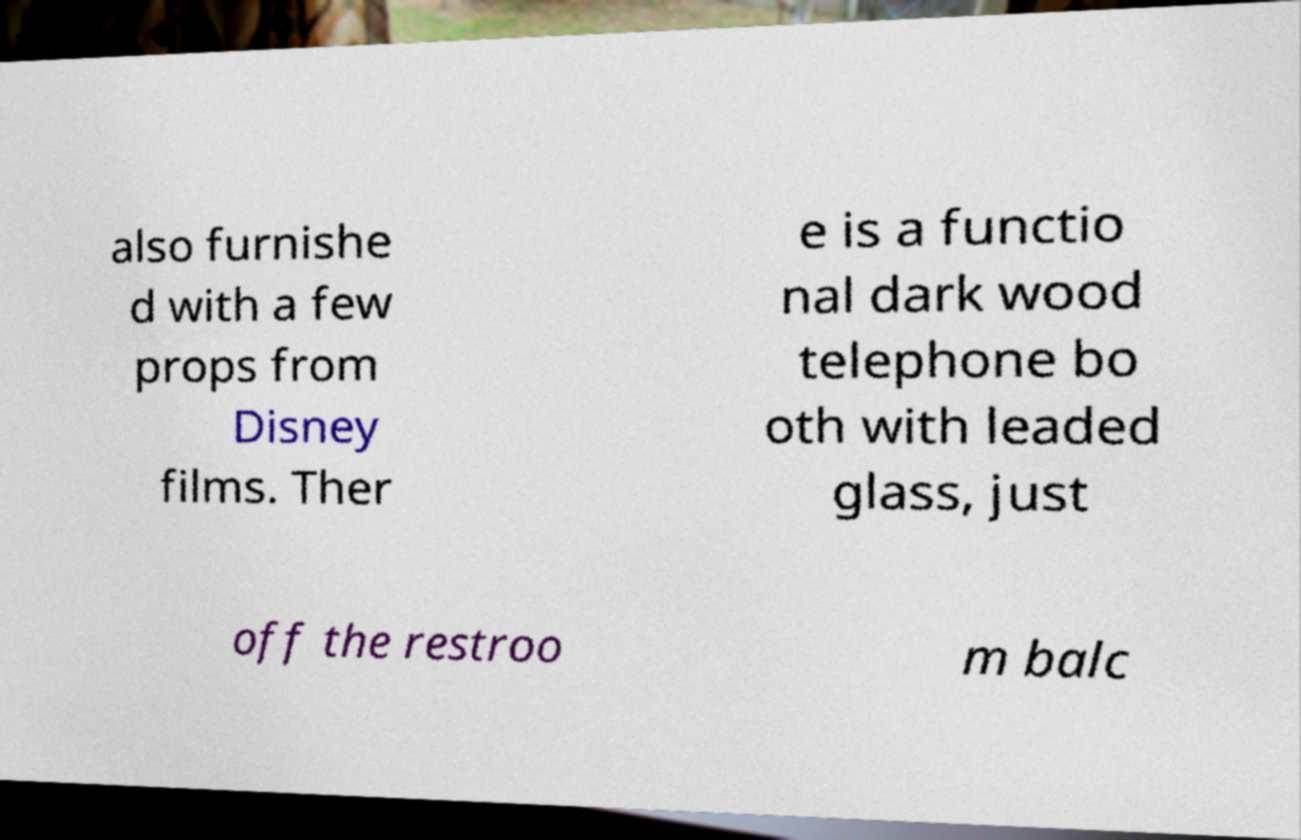Can you read and provide the text displayed in the image?This photo seems to have some interesting text. Can you extract and type it out for me? also furnishe d with a few props from Disney films. Ther e is a functio nal dark wood telephone bo oth with leaded glass, just off the restroo m balc 